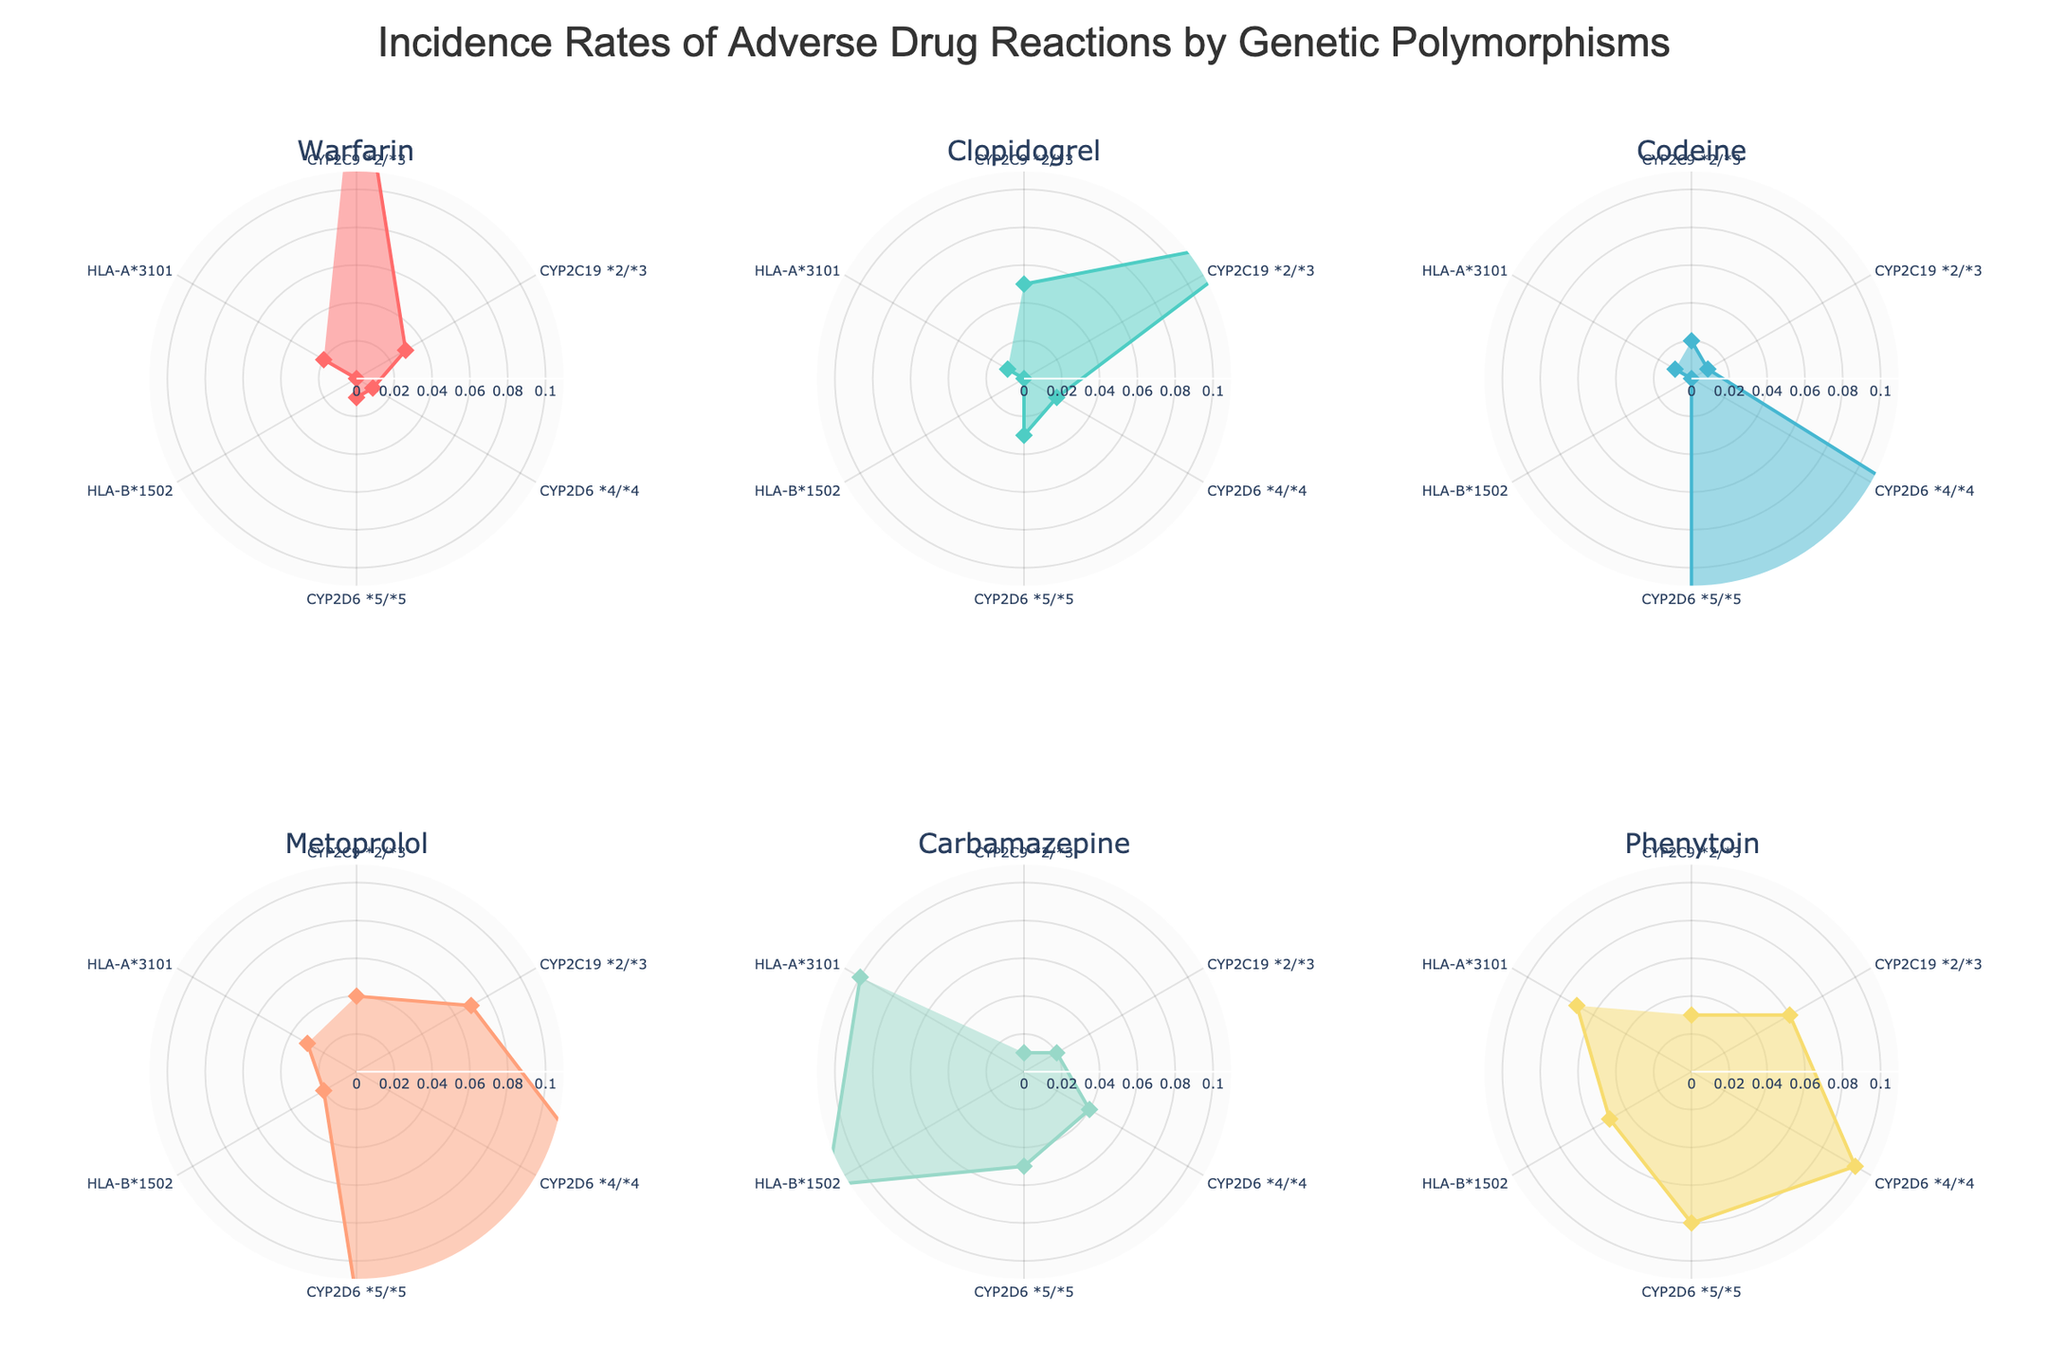What is the title of the figure? The title of the figure is usually displayed at the top. In this case, it is "Incidence Rates of Adverse Drug Reactions by Genetic Polymorphisms".
Answer: Incidence Rates of Adverse Drug Reactions by Genetic Polymorphisms How many genetic polymorphisms are represented in the radar charts? Genetic polymorphisms are typically indicated along the radial axis. Counting them, we have six: CYP2C9 *2/*3, CYP2C19 *2/*3, CYP2D6 *4/*4, CYP2D6 *5/*5, HLA-B*1502, and HLA-A*3101.
Answer: 6 Which drug has the highest incidence rate of adverse drug reactions for the genetic polymorphism CYP2D6 *4/*4? By looking at the radar charts, check the incidence rates for each drug under the genetic polymorphism CYP2D6 *4/*4. Codeine has the highest rate at 0.25.
Answer: Codeine Which genetic polymorphism is associated with the lowest incidence rate of adverse reactions for Warfarin and what is the rate? Reviewing the Warfarin radar chart, the lowest incidence rate is 0.00, associated with HLA-B*1502.
Answer: HLA-B*1502, 0.00 Compare the incidence rates for Metoprolol and Carbamazepine among individuals with the genetic polymorphism CYP2C19 *2/*3. Which drug has a higher incidence rate? In the radar charts, locate the incidence rates for Metoprolol (0.07) and Carbamazepine (0.02) for the genetic polymorphism CYP2C19 *2/*3. Metoprolol has a higher incidence rate.
Answer: Metoprolol What is the average incidence rate of adverse drug reactions for Clopidogrel across all genetic polymorphisms? Sum the incidence rates of Clopidogrel for each genetic polymorphism: 0.05, 0.15, 0.02, 0.03, 0.00, 0.01, resulting in 0.26. Divide by the number of genetic polymorphisms (6) to get the average: 0.26/6 ≈ 0.043.
Answer: 0.043 Which two drugs have the most similar incidence rate distributions across the genetic polymorphisms? By visually inspecting the radar charts for patterns, Clopidogrel and Warfarin seem to have the most similar distribution shapes and values.
Answer: Clopidogrel and Warfarin For genetic polymorphism HLA-A*3101, which drug shows the highest and lowest incidence rates of adverse reactions? For HLA-A*3101 in the radar charts, evaluate the highest (Carbamazepine: 0.10) and lowest (Clopidogrel: 0.01) incidence rates.
Answer: Highest: Carbamazepine, Lowest: Clopidogrel What is the range of incidence rates for Phenytoin among all genetic polymorphisms? The range is the difference between the maximum and minimum values. For Phenytoin, the maximum rate is 0.10 (CYP2D6 *4/*4) and the minimum is 0 (HLA-B*1502), resulting in a range of 0.10 - 0 = 0.10.
Answer: 0.10 